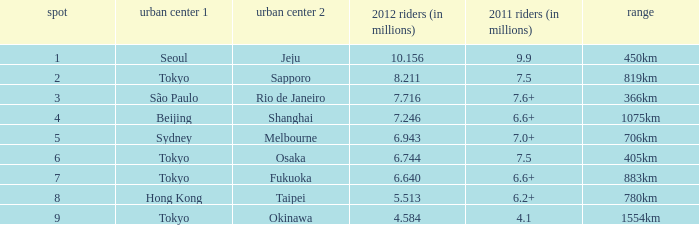Give me the full table as a dictionary. {'header': ['spot', 'urban center 1', 'urban center 2', '2012 riders (in millions)', '2011 riders (in millions)', 'range'], 'rows': [['1', 'Seoul', 'Jeju', '10.156', '9.9', '450km'], ['2', 'Tokyo', 'Sapporo', '8.211', '7.5', '819km'], ['3', 'São Paulo', 'Rio de Janeiro', '7.716', '7.6+', '366km'], ['4', 'Beijing', 'Shanghai', '7.246', '6.6+', '1075km'], ['5', 'Sydney', 'Melbourne', '6.943', '7.0+', '706km'], ['6', 'Tokyo', 'Osaka', '6.744', '7.5', '405km'], ['7', 'Tokyo', 'Fukuoka', '6.640', '6.6+', '883km'], ['8', 'Hong Kong', 'Taipei', '5.513', '6.2+', '780km'], ['9', 'Tokyo', 'Okinawa', '4.584', '4.1', '1554km']]} Which city is listed first when Okinawa is listed as the second city? Tokyo. 